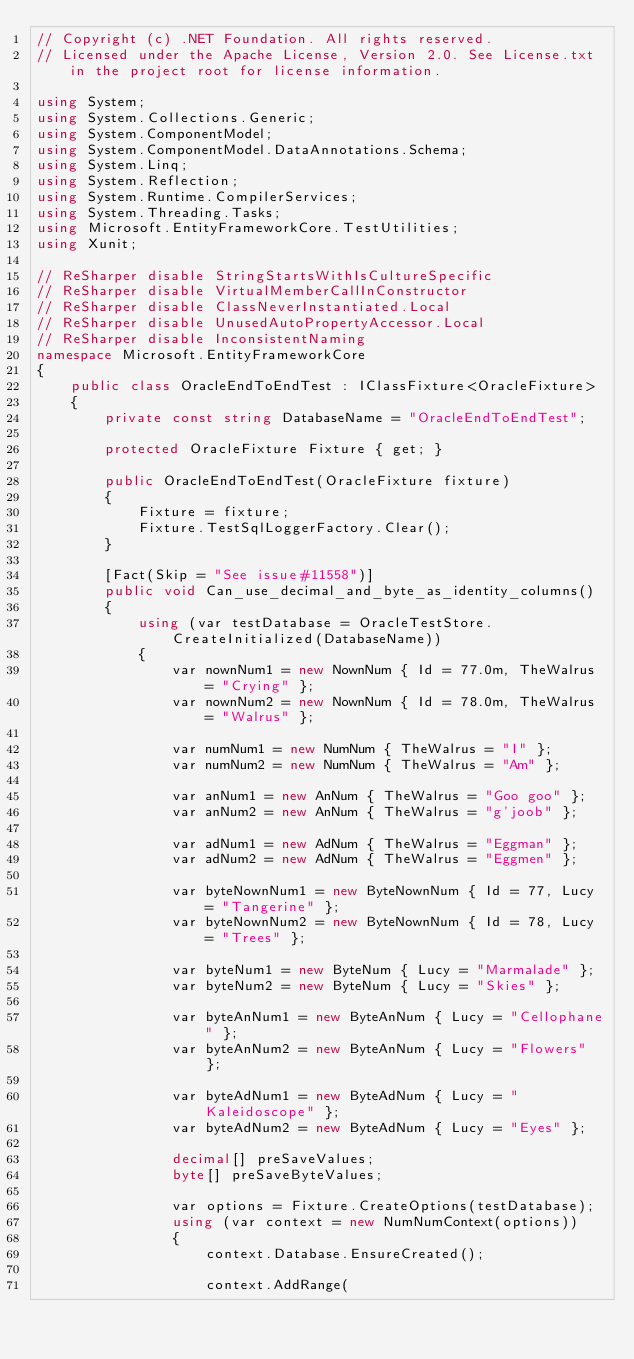<code> <loc_0><loc_0><loc_500><loc_500><_C#_>// Copyright (c) .NET Foundation. All rights reserved.
// Licensed under the Apache License, Version 2.0. See License.txt in the project root for license information.

using System;
using System.Collections.Generic;
using System.ComponentModel;
using System.ComponentModel.DataAnnotations.Schema;
using System.Linq;
using System.Reflection;
using System.Runtime.CompilerServices;
using System.Threading.Tasks;
using Microsoft.EntityFrameworkCore.TestUtilities;
using Xunit;

// ReSharper disable StringStartsWithIsCultureSpecific
// ReSharper disable VirtualMemberCallInConstructor
// ReSharper disable ClassNeverInstantiated.Local
// ReSharper disable UnusedAutoPropertyAccessor.Local
// ReSharper disable InconsistentNaming
namespace Microsoft.EntityFrameworkCore
{
    public class OracleEndToEndTest : IClassFixture<OracleFixture>
    {
        private const string DatabaseName = "OracleEndToEndTest";

        protected OracleFixture Fixture { get; }

        public OracleEndToEndTest(OracleFixture fixture)
        {
            Fixture = fixture;
            Fixture.TestSqlLoggerFactory.Clear();
        }

        [Fact(Skip = "See issue#11558")]
        public void Can_use_decimal_and_byte_as_identity_columns()
        {
            using (var testDatabase = OracleTestStore.CreateInitialized(DatabaseName))
            {
                var nownNum1 = new NownNum { Id = 77.0m, TheWalrus = "Crying" };
                var nownNum2 = new NownNum { Id = 78.0m, TheWalrus = "Walrus" };

                var numNum1 = new NumNum { TheWalrus = "I" };
                var numNum2 = new NumNum { TheWalrus = "Am" };

                var anNum1 = new AnNum { TheWalrus = "Goo goo" };
                var anNum2 = new AnNum { TheWalrus = "g'joob" };

                var adNum1 = new AdNum { TheWalrus = "Eggman" };
                var adNum2 = new AdNum { TheWalrus = "Eggmen" };

                var byteNownNum1 = new ByteNownNum { Id = 77, Lucy = "Tangerine" };
                var byteNownNum2 = new ByteNownNum { Id = 78, Lucy = "Trees" };

                var byteNum1 = new ByteNum { Lucy = "Marmalade" };
                var byteNum2 = new ByteNum { Lucy = "Skies" };

                var byteAnNum1 = new ByteAnNum { Lucy = "Cellophane" };
                var byteAnNum2 = new ByteAnNum { Lucy = "Flowers" };

                var byteAdNum1 = new ByteAdNum { Lucy = "Kaleidoscope" };
                var byteAdNum2 = new ByteAdNum { Lucy = "Eyes" };

                decimal[] preSaveValues;
                byte[] preSaveByteValues;

                var options = Fixture.CreateOptions(testDatabase);
                using (var context = new NumNumContext(options))
                {
                    context.Database.EnsureCreated();

                    context.AddRange(</code> 